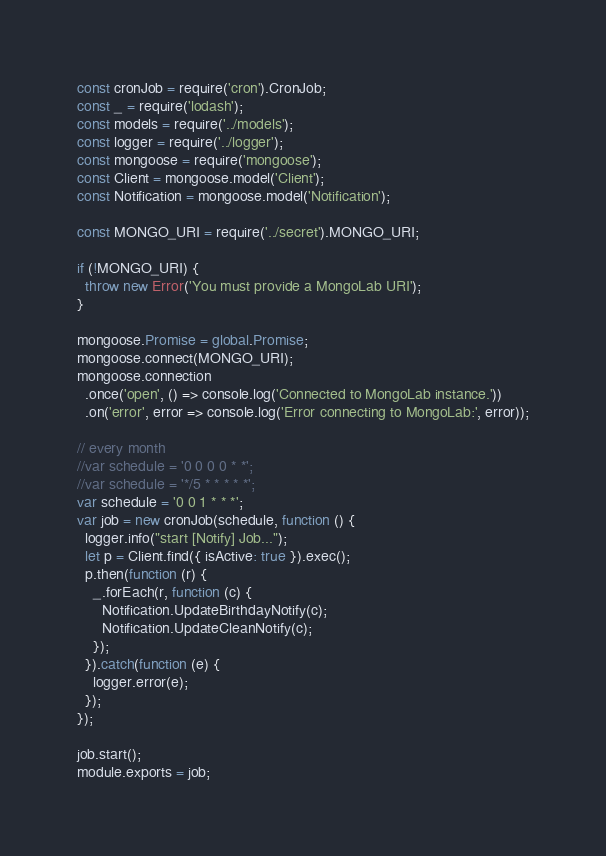Convert code to text. <code><loc_0><loc_0><loc_500><loc_500><_JavaScript_>const cronJob = require('cron').CronJob;
const _ = require('lodash');
const models = require('../models');
const logger = require('../logger');
const mongoose = require('mongoose');
const Client = mongoose.model('Client');
const Notification = mongoose.model('Notification');

const MONGO_URI = require('../secret').MONGO_URI;

if (!MONGO_URI) {
  throw new Error('You must provide a MongoLab URI');
}

mongoose.Promise = global.Promise;
mongoose.connect(MONGO_URI);
mongoose.connection
  .once('open', () => console.log('Connected to MongoLab instance.'))
  .on('error', error => console.log('Error connecting to MongoLab:', error));

// every month 
//var schedule = '0 0 0 0 * *';
//var schedule = '*/5 * * * * *';
var schedule = '0 0 1 * * *';
var job = new cronJob(schedule, function () {
  logger.info("start [Notify] Job...");
  let p = Client.find({ isActive: true }).exec();
  p.then(function (r) {
    _.forEach(r, function (c) {
      Notification.UpdateBirthdayNotify(c);
      Notification.UpdateCleanNotify(c);
    });
  }).catch(function (e) {
    logger.error(e);
  });
});

job.start();
module.exports = job;
</code> 